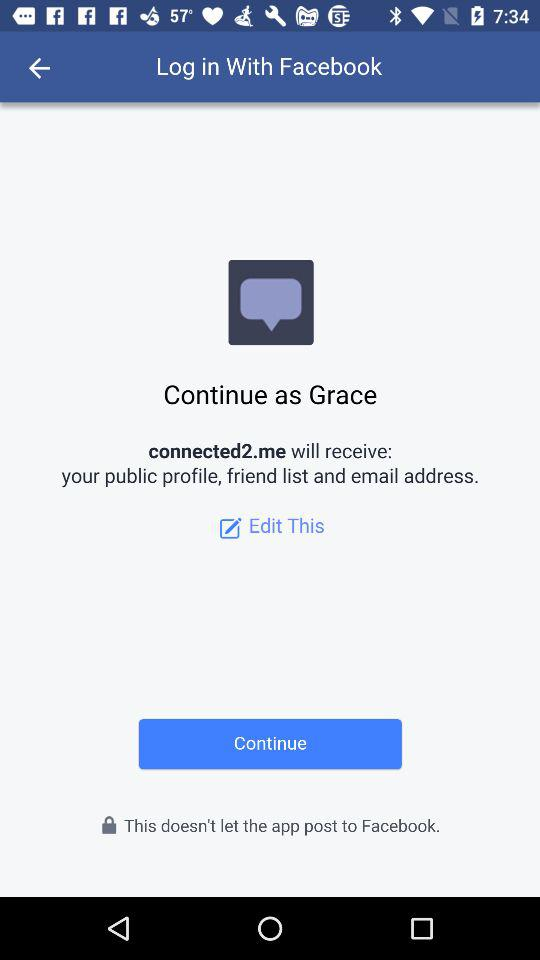What is the user name to continue the profile? The user name is Grace. 